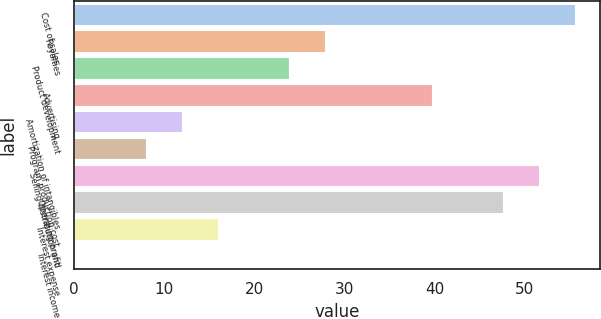<chart> <loc_0><loc_0><loc_500><loc_500><bar_chart><fcel>Cost of sales<fcel>Royalties<fcel>Product development<fcel>Advertising<fcel>Amortization of intangibles<fcel>Program production cost<fcel>Selling distribution and<fcel>Operating profit<fcel>Interest expense<fcel>Interest income<nl><fcel>55.54<fcel>27.82<fcel>23.86<fcel>39.7<fcel>11.98<fcel>8.02<fcel>51.58<fcel>47.62<fcel>15.94<fcel>0.1<nl></chart> 